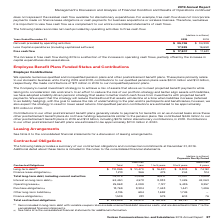According to Verizon Communications's financial document, How is free cash flow calculated? Based on the financial document, the answer is by subtracting capital expenditures from net cash provided by operating activities. We believe it is a more conservative measure of cash flow since purchases of fixed assets are necessary for ongoing operations.. Also, What was the Less Capital expenditures (including capitalized software) in 2019? According to the financial document, 17,939 (in millions). The relevant text states: "tal expenditures (including capitalized software) 17,939 16,658..." Also, What was the free cash flow in 2019? According to the financial document, $ 17,807 (in millions). The relevant text states: "Free cash flow $ 17,807 $ 17,681..." Also, can you calculate: What was the change in the net cash provided by operating activities from 2018 to 2019? Based on the calculation: 35,746 - 34,339, the result is 1407 (in millions). This is based on the information: "cash provided by operating activities $ 35,746 $ 34,339 Net cash provided by operating activities $ 35,746 $ 34,339..." The key data points involved are: 34,339, 35,746. Also, can you calculate: What was the average free cash flow for 2018 and 2019? To answer this question, I need to perform calculations using the financial data. The calculation is: (17,807 + 17,681) / 2, which equals 17744 (in millions). This is based on the information: "Free cash flow $ 17,807 $ 17,681 Free cash flow $ 17,807 $ 17,681..." The key data points involved are: 17,681, 17,807. Also, can you calculate: What was the percentage change in the Less Capital expenditures from 2018 to 2019? To answer this question, I need to perform calculations using the financial data. The calculation is: 17,939 / 16,658 - 1, which equals 7.69 (percentage). This is based on the information: "tal expenditures (including capitalized software) 17,939 16,658 enditures (including capitalized software) 17,939 16,658..." The key data points involved are: 16,658, 17,939. 